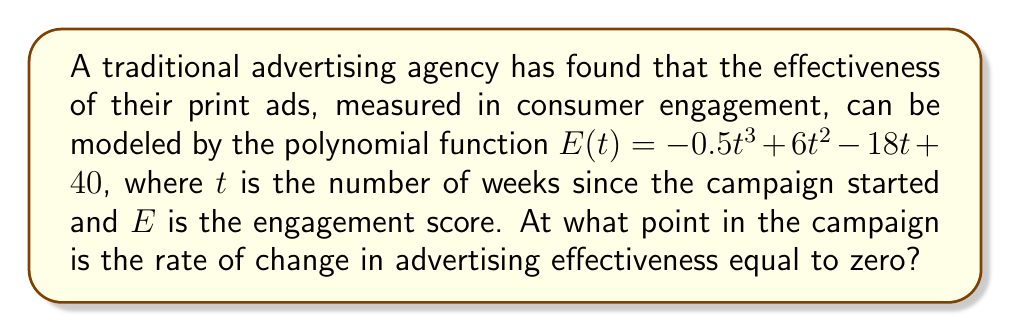Can you answer this question? To solve this problem, we need to follow these steps:

1. The rate of change in advertising effectiveness is represented by the first derivative of the function $E(t)$.

2. Calculate the first derivative:
   $$E'(t) = \frac{d}{dt}(-0.5t^3 + 6t^2 - 18t + 40)$$
   $$E'(t) = -1.5t^2 + 12t - 18$$

3. To find when the rate of change is zero, set $E'(t) = 0$:
   $$-1.5t^2 + 12t - 18 = 0$$

4. This is a quadratic equation. We can solve it using the quadratic formula:
   $$t = \frac{-b \pm \sqrt{b^2 - 4ac}}{2a}$$
   where $a = -1.5$, $b = 12$, and $c = -18$

5. Substituting these values:
   $$t = \frac{-12 \pm \sqrt{12^2 - 4(-1.5)(-18)}}{2(-1.5)}$$
   $$t = \frac{-12 \pm \sqrt{144 - 108}}{-3}$$
   $$t = \frac{-12 \pm \sqrt{36}}{-3}$$
   $$t = \frac{-12 \pm 6}{-3}$$

6. This gives us two solutions:
   $$t = \frac{-12 + 6}{-3} = 2$$ or $$t = \frac{-12 - 6}{-3} = 6$$

Therefore, the rate of change in advertising effectiveness is equal to zero at 2 weeks and 6 weeks into the campaign.
Answer: 2 weeks and 6 weeks 